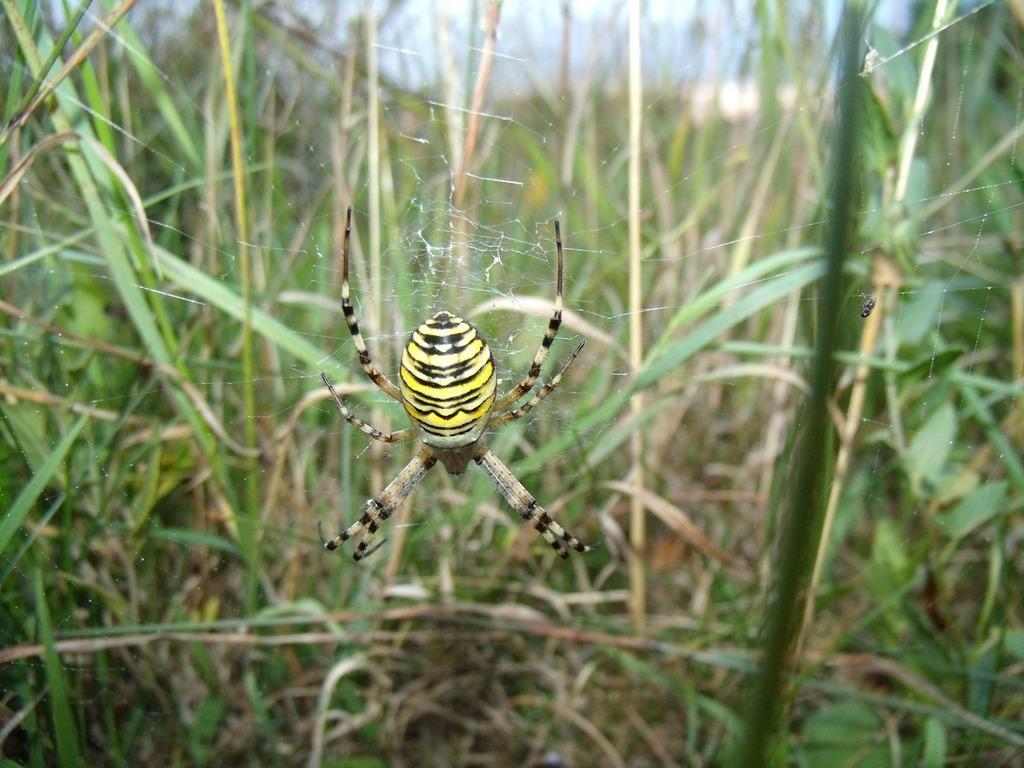Could you give a brief overview of what you see in this image? In this image we can see a spider on the web. On the backside we can see some plants and the sky. 